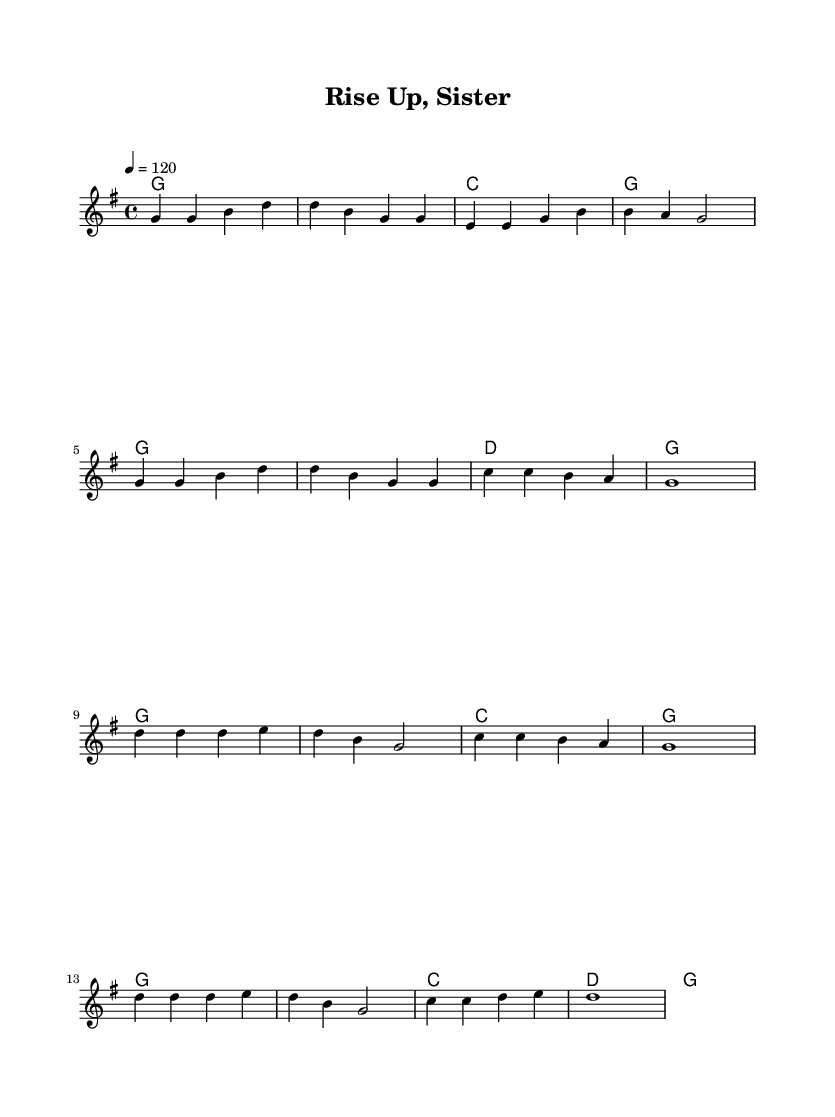What is the key signature of this music? The key signature is G major, which has one sharp (F#). This is evident from the global settings section in the code where it specifies \key g \major.
Answer: G major What is the time signature of this music? The time signature is 4/4, which can be found under the global settings in the code where \time 4/4 is indicated. This means there are four beats in a measure and the quarter note gets one beat.
Answer: 4/4 What is the tempo of the piece? The tempo is set to 120 beats per minute, as indicated by the instruction \tempo 4 = 120 in the global section. This tells us how fast the piece should be played.
Answer: 120 How many verses are there in the melody? The melody section indicates two verses, as seen in the first set of lines coded in the melody variable; each verse is represented by the sequence of notes followed by the chorus section.
Answer: Two What is the starting chord of the first verse? The starting chord of the first verse is G major, which is the first chord written in the harmonies section of the code under the verse section, specifically after the first line.
Answer: G What is the harmonic progression of the chorus? The harmonic progression of the chorus alternates between G major and C major, as shown in the harmonies section where the chords listed for the chorus are G, G, C, and G, followed by G, G, C, and D, finishing with G.
Answer: G, C 